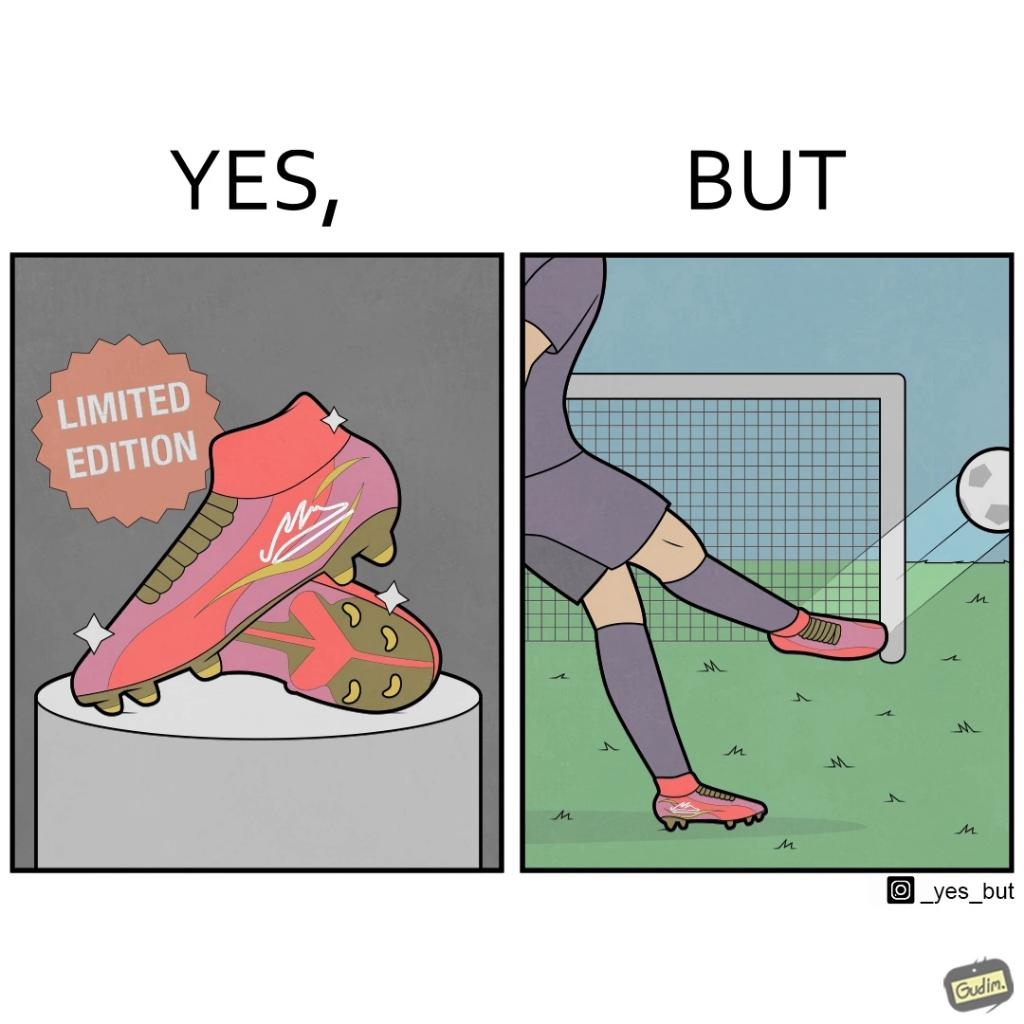Describe the contrast between the left and right parts of this image. In the left part of the image: It is a pair of expensive looking limited edition football boots In the right part of the image: It is a man shooting a football wide outside a goalpost 